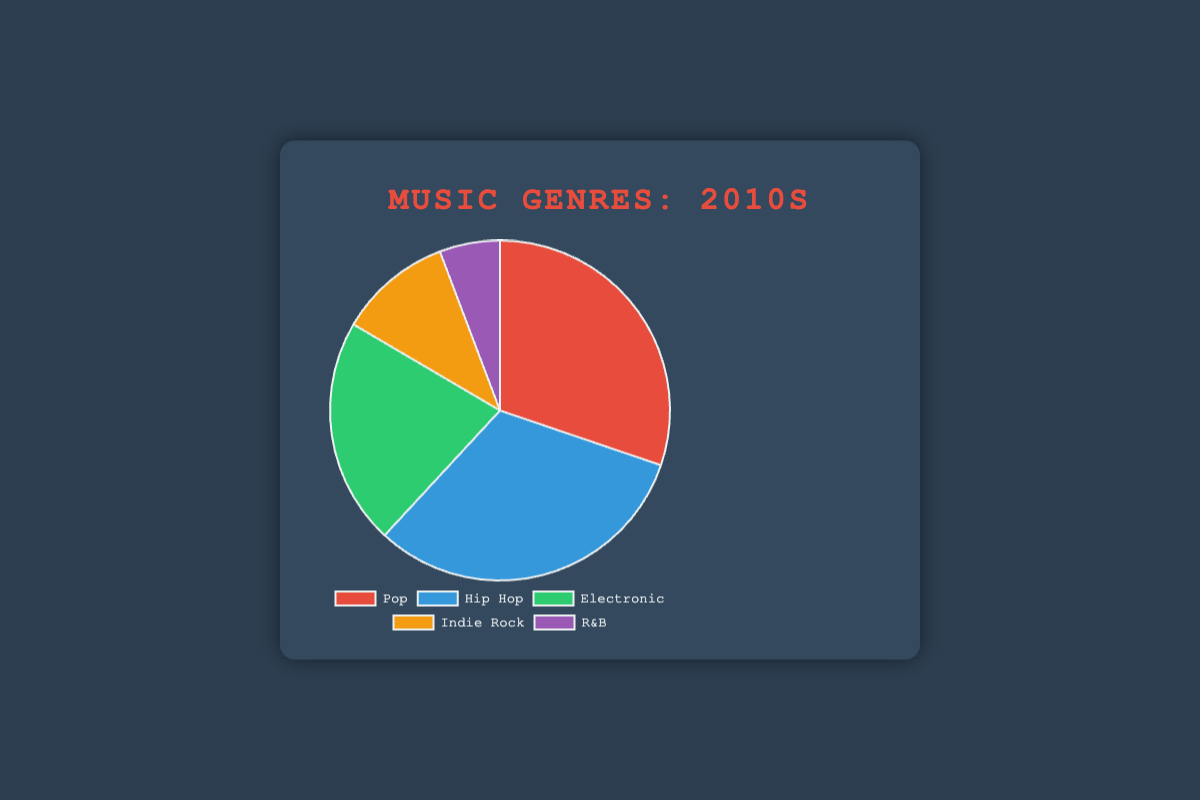What is the genre with the highest number of album releases in the 2010s? By looking at the pie chart, observe the largest segment. The largest segment represents Hip Hop.
Answer: Hip Hop How many more albums did Pop have compared to R&B in the 2010s? From the data, Pop had 210 albums and R&B had 40 albums. Calculate the difference: 210 - 40 = 170.
Answer: 170 Which genre had the smallest number of album releases in the 2010s? Identify the smallest segment in the pie chart. The smallest segment represents R&B.
Answer: R&B What is the combined total of album releases for Pop and Hip Hop in the 2010s? Sum the album releases of Pop (210) and Hip Hop (220). Thus, 210 + 220 = 430.
Answer: 430 What percentage of the total album releases in the 2010s does Electronic represent? Calculate the total number of albums released in the 2010s: 210 (Pop) + 220 (Hip Hop) + 150 (Electronic) + 75 (Indie Rock) + 40 (R&B) = 695. Then divide Electronic albums by the total and multiply by 100. (150/695) * 100 ≈ 21.6%.
Answer: 21.6% How does the number of Electronic album releases compare to Indie Rock in the 2010s? By comparing the numbers from the data, Electronic has 150 album releases and Indie Rock has 75. 150 is greater than 75.
Answer: Electronic is greater Which genre has more releases: R&B in the 2010s or Heavy Metal in the 1980s? By referring to the data, R&B in the 2010s had 40 releases, and Heavy Metal in the 1980s had 60 releases. 60 is greater than 40.
Answer: Heavy Metal What is the average number of album releases for the five genres in the 2010s? Add the album releases for each genre (210 for Pop, 220 for Hip Hop, 150 for Electronic, 75 for Indie Rock, and 40 for R&B) and then divide by the number of genres (5). (210 + 220 + 150 + 75 + 40) / 5 = 695 / 5 = 139.
Answer: 139 